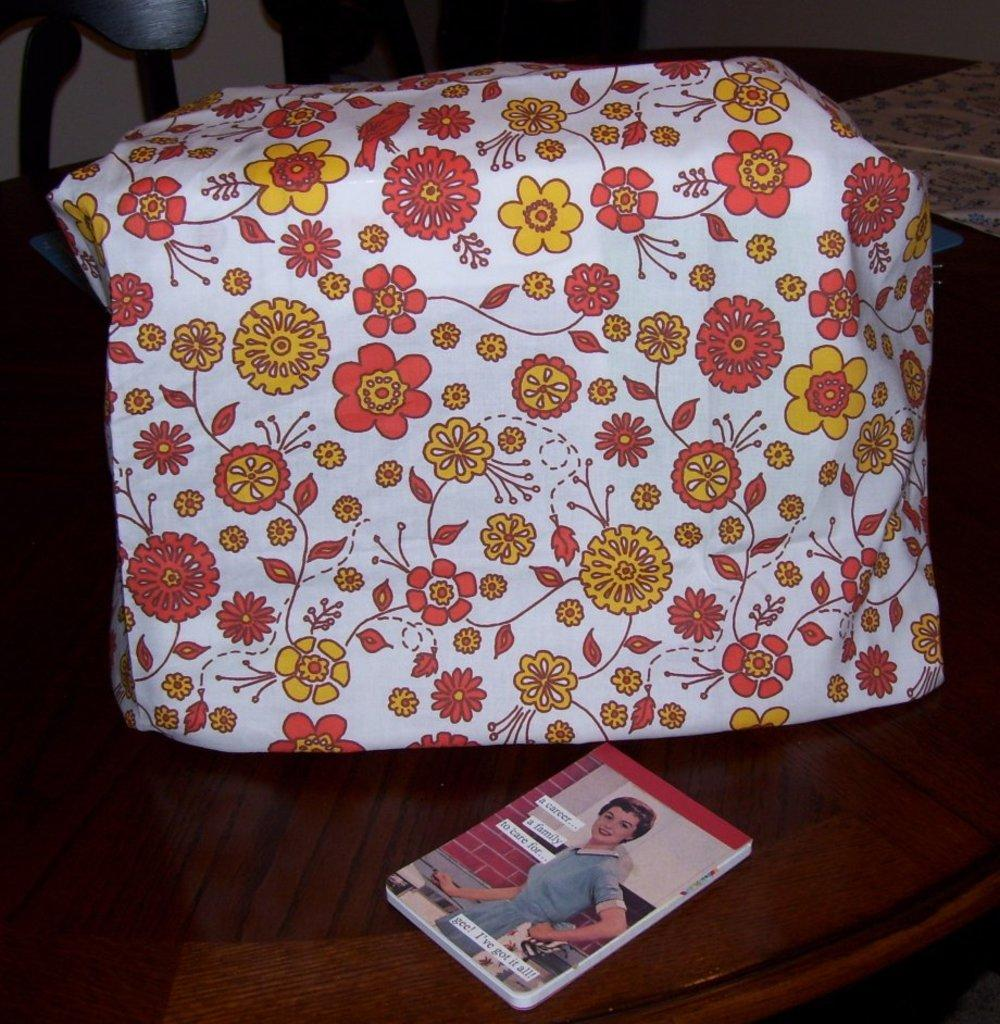What type of furniture is present in the image? There is a table in the image. What is placed on the table? There is a book and a package on the table. What type of waves can be seen in the image? There are no waves present in the image; it features a table with a book and a package on it. Is there any coal visible in the image? There is no coal present in the image. 